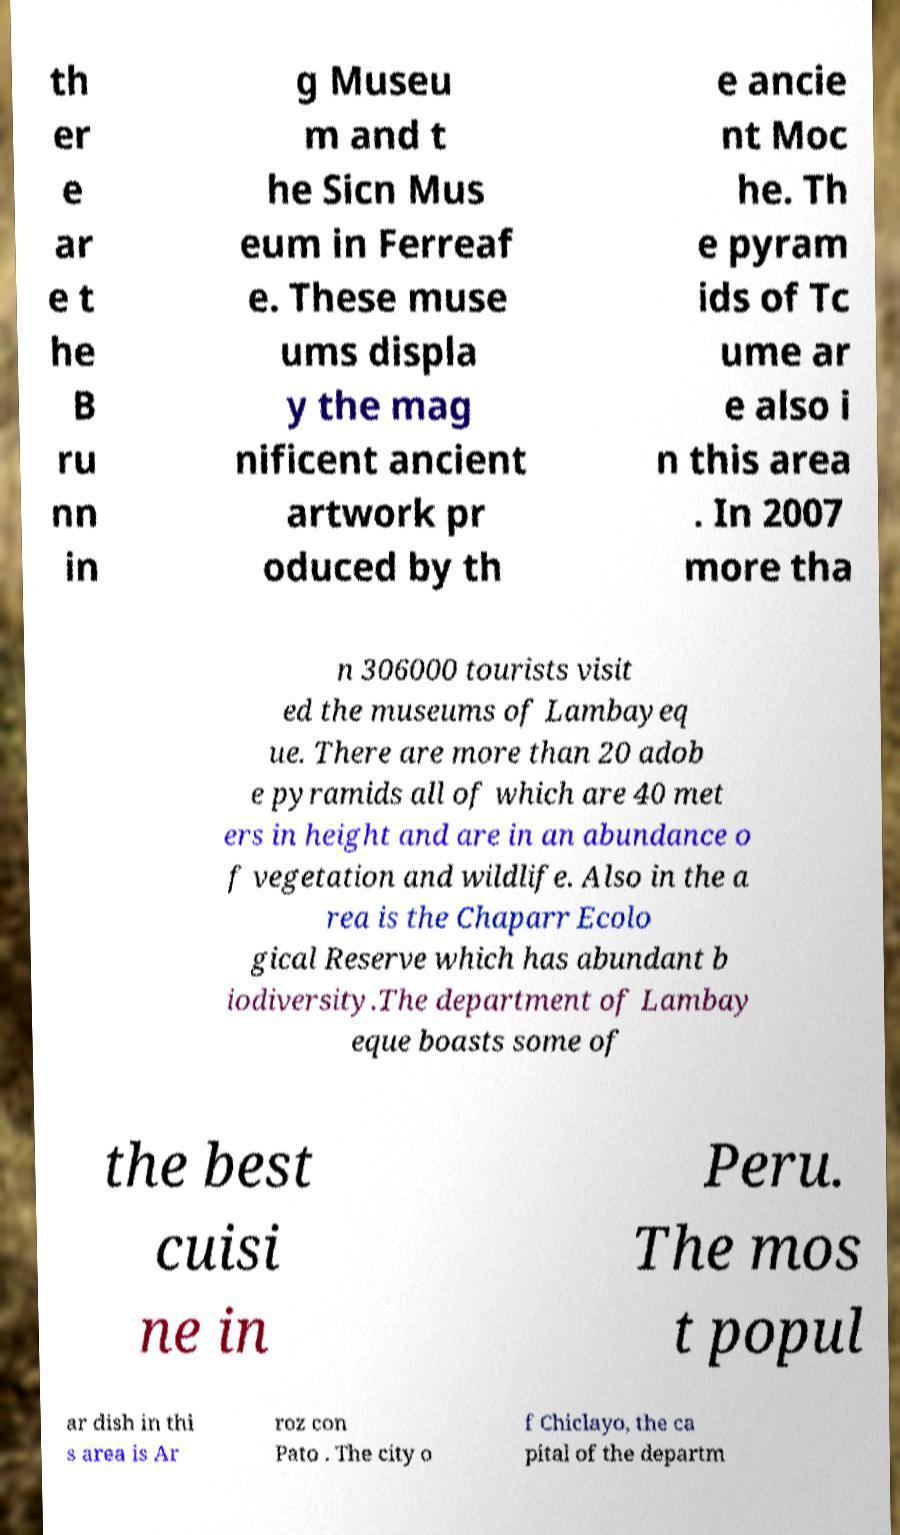I need the written content from this picture converted into text. Can you do that? th er e ar e t he B ru nn in g Museu m and t he Sicn Mus eum in Ferreaf e. These muse ums displa y the mag nificent ancient artwork pr oduced by th e ancie nt Moc he. Th e pyram ids of Tc ume ar e also i n this area . In 2007 more tha n 306000 tourists visit ed the museums of Lambayeq ue. There are more than 20 adob e pyramids all of which are 40 met ers in height and are in an abundance o f vegetation and wildlife. Also in the a rea is the Chaparr Ecolo gical Reserve which has abundant b iodiversity.The department of Lambay eque boasts some of the best cuisi ne in Peru. The mos t popul ar dish in thi s area is Ar roz con Pato . The city o f Chiclayo, the ca pital of the departm 